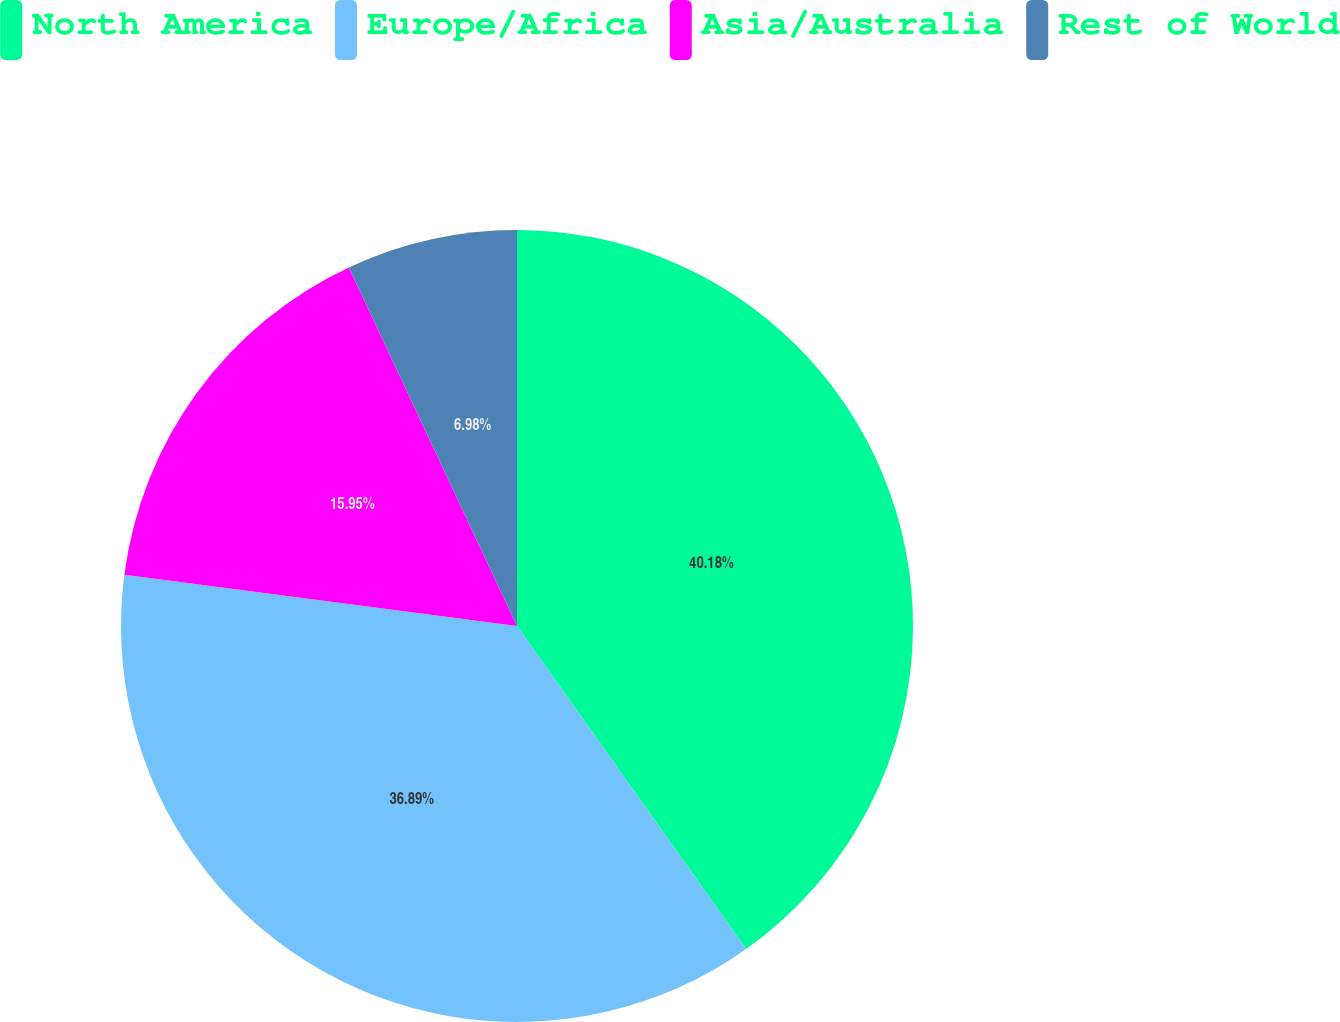Convert chart to OTSL. <chart><loc_0><loc_0><loc_500><loc_500><pie_chart><fcel>North America<fcel>Europe/Africa<fcel>Asia/Australia<fcel>Rest of World<nl><fcel>40.18%<fcel>36.89%<fcel>15.95%<fcel>6.98%<nl></chart> 